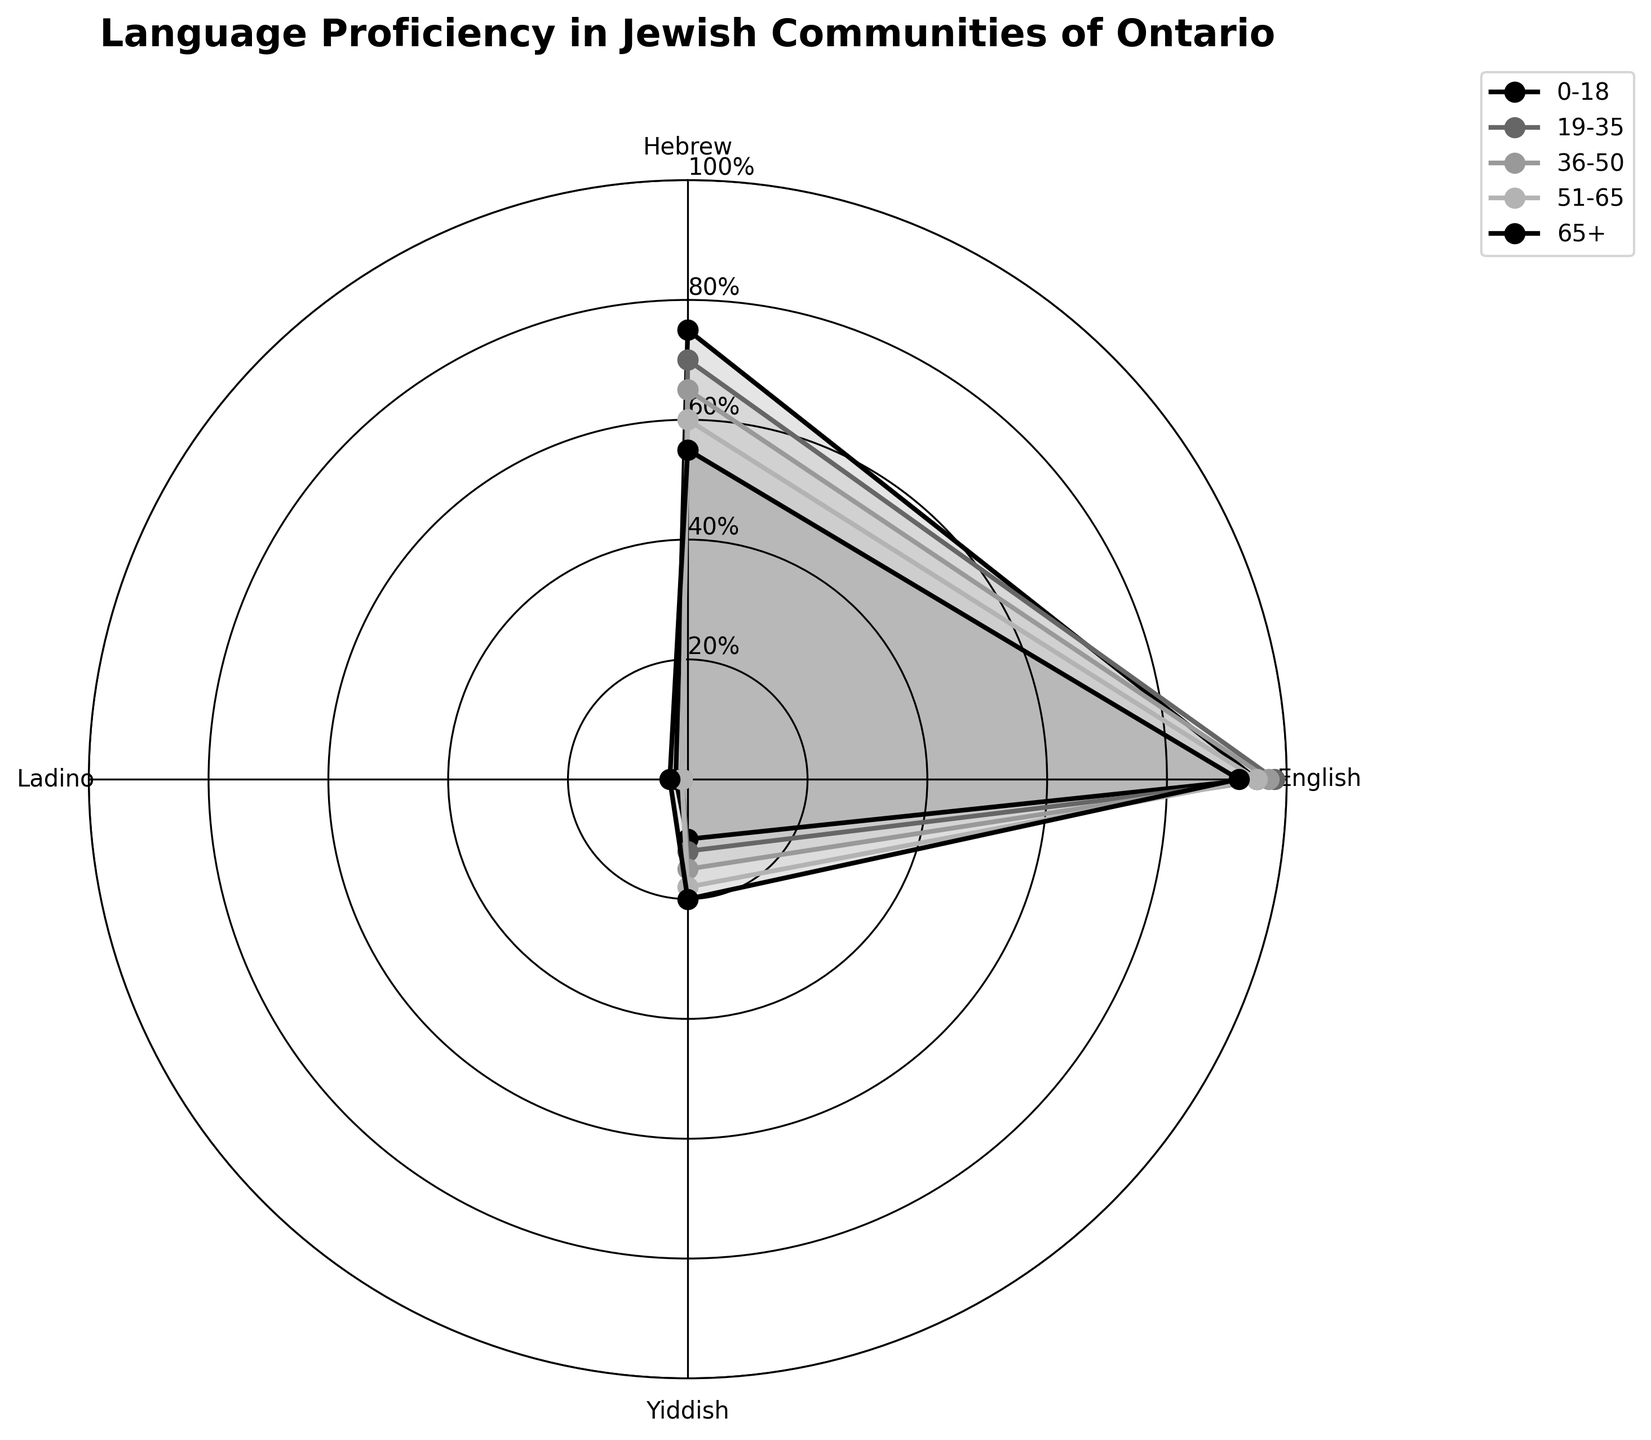What's the title of the chart? The title of the chart is displayed at the top and reads "Language Proficiency in Jewish Communities of Ontario".
Answer: Language Proficiency in Jewish Communities of Ontario What age group has the highest proficiency in English? By examining the chart, we see that all age groups have high proficiency in English, but the 19-35 age group has the highest proficiency, slightly above the others.
Answer: 19-35 Which age group shows highest proficiency in Hebrew? Looking at the lines corresponding to each age group and focusing on the Hebrew axis, we see that the 0-18 age group has the highest proficiency in Hebrew.
Answer: 0-18 What age group has the lowest proficiency in Ladino? Each age group has very low proficiency in Ladino, but the 19-35 age group shows the lowest values.
Answer: 19-35 Compare Yiddish proficiency between the age groups 51-65 and 65+. Which is higher? Observing the individual points for Yiddish proficiency on the chart for the age groups 51-65 and 65+, we see that the 65+ age group has slightly higher proficiency.
Answer: 65+ How does proficiency in Yiddish change as the age increases? To answer this, follow the Yiddish points for each age group from 0-18 through 65+. There is a visible trend showing that proficiency in Yiddish increases with age.
Answer: Increases Which age group shows the most balanced proficiency in all languages? Balance can be interpreted as the least deviation from the average proficiency levels across languages. By comparing the spreads, the 19-35 age group appears to be the most balanced across all languages.
Answer: 19-35 Calculate the average proficiency in Hebrew for all age groups. Sum all Hebrew proficiency values (75 + 70 + 65 + 60 + 55) and divide by the number of age groups (5): (75 + 70 + 65 + 60 + 55)/5 = 65.
Answer: 65 What is the difference in Hebrew proficiency between the 0-18 and 19-35 age groups? Subtract the 19-35 Hebrew proficiency from the 0-18 Hebrew proficiency: 75 - 70 = 5.
Answer: 5 Identify which language has the least proficiency across all age groups. By examining the chart, Ladino consistently has the lowest proficiency levels across all age groups compared to Hebrew, English, and Yiddish.
Answer: Ladino 